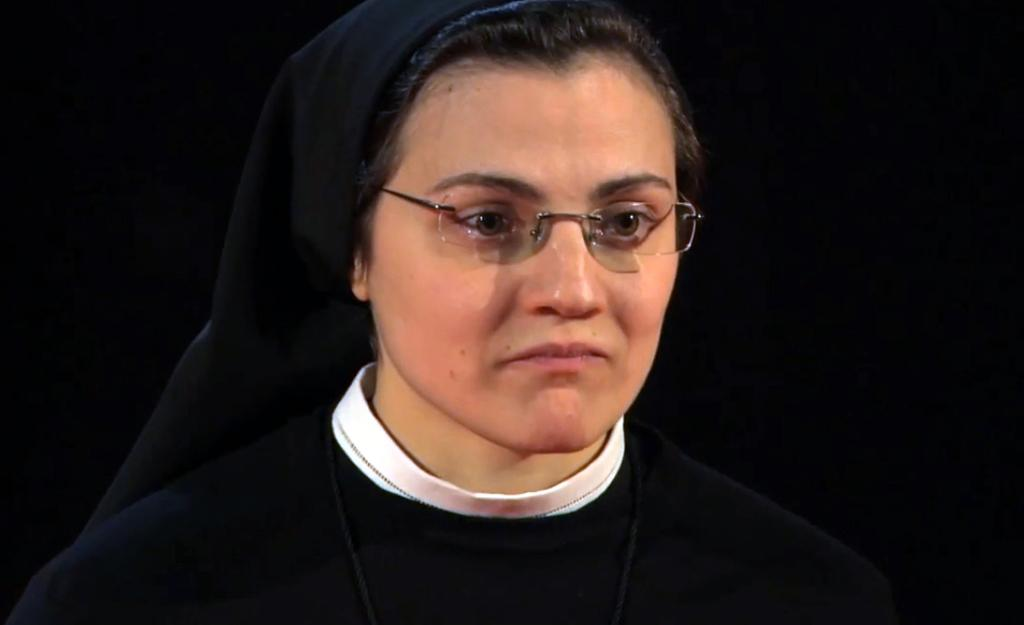Who is the main subject in the image? There is a lady in the image. What can be observed about the background of the image? The background of the image is dark. What type of horn can be heard in the image? There is no horn or sound present in the image, as it is a still image. 